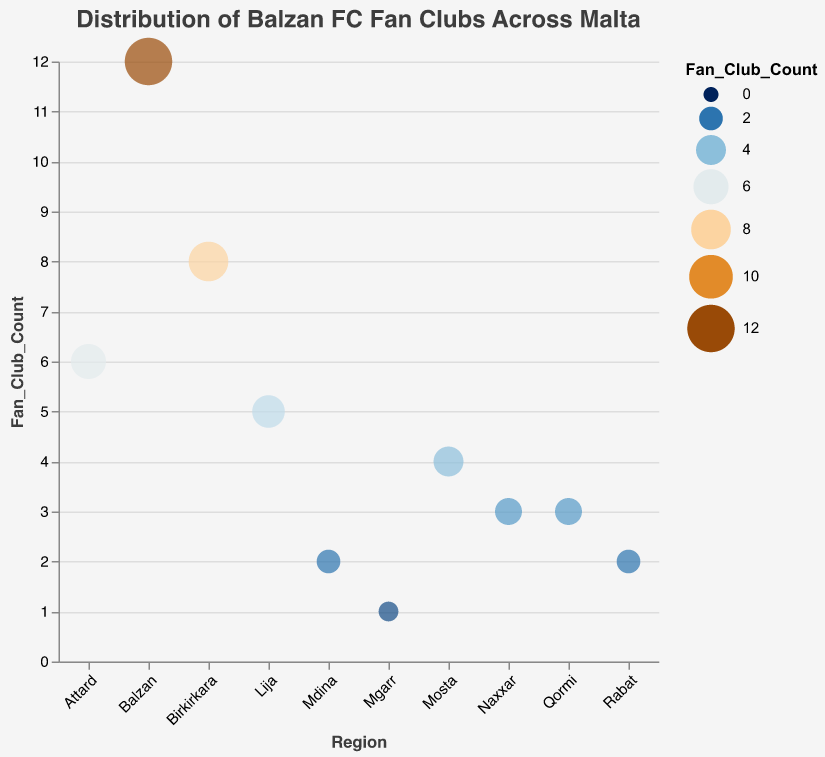what is the title of the plot? The title of the plot is displayed at the top and reads "Distribution of Balzan FC Fan Clubs Across Malta".
Answer: "Distribution of Balzan FC Fan Clubs Across Malta" How many fan clubs are there in Birkirkara? The y-axis shows the count of fan clubs, and for Birkirkara, the circle marker is at the position marking 8 fan clubs.
Answer: 8 Which region has the highest number of fan clubs? The region with the highest circle marker on the y-axis, corresponding to a Fan Club Count of 12, is marked as Balzan.
Answer: Balzan Which regions have an equal number of fan clubs? By comparing circle markers on the y-axis, both Naxxar and Qormi regions have circle markers at the same position, indicating they each have 3 fan clubs.
Answer: Naxxar and Qormi What color range is used in the plot to represent the number of fan clubs? The color range of the plot used to represent the Fan Club Count includes a gradient that transitions from blue to orange.
Answer: Blue to orange What is the fan count difference between Lija and Mdina? The fan club count for Lija is 5 and for Mdina is 2. The difference can be calculated as 5 - 2 = 3.
Answer: 3 What is the average number of fan clubs in the regions shown? Sum all the Fan Club Counts (12 + 8 + 6 + 5 + 4 + 3 + 3 + 2 + 2 + 1 = 46) and divide by the number of regions (10), giving an average of 46/10 = 4.6.
Answer: 4.6 Which notable member is highlighted in Balzan? The tooltip reveals the "Notable_Member" for Balzan, which is André Fausto.
Answer: André Fausto How do the sizes of the circle markers vary in the plot? The sizes of the circle markers vary with the number of fan clubs; larger circles represent regions with more fan clubs. The smallest marker represents 1 fan club while the largest represents 12 fan clubs.
Answer: Larger circles indicate more fan clubs, and smaller circles indicate fewer fan clubs How does the Fan Club Count in Mosta compare to that in Attard? The circle marker for Mosta indicates a Fan Club Count of 4, while Attard's circle marker indicates a count of 6; hence, Attard has 2 more fan clubs than Mosta.
Answer: Attard has 2 more 